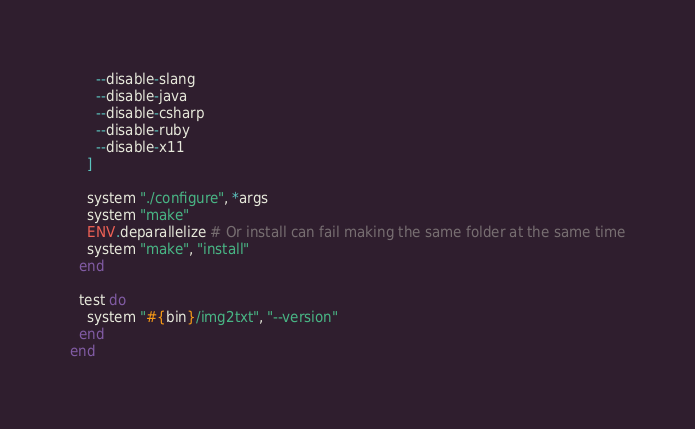Convert code to text. <code><loc_0><loc_0><loc_500><loc_500><_Ruby_>      --disable-slang
      --disable-java
      --disable-csharp
      --disable-ruby
      --disable-x11
    ]

    system "./configure", *args
    system "make"
    ENV.deparallelize # Or install can fail making the same folder at the same time
    system "make", "install"
  end

  test do
    system "#{bin}/img2txt", "--version"
  end
end
</code> 